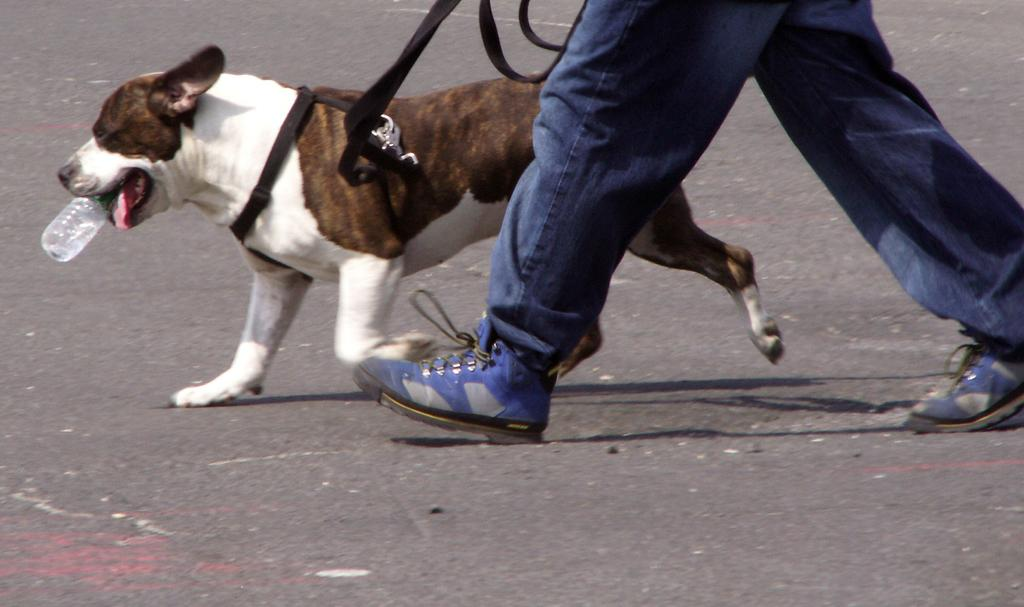What is the main subject of the image? The main subject of the image is a person walking on a road. What is the person holding in their hand? The person is holding a dog in their hand. What is the dog doing in the image? The dog has a bottle in its mouth. What type of berry is the person eating in the image? There is no berry present in the image; the person is walking and holding a dog. 